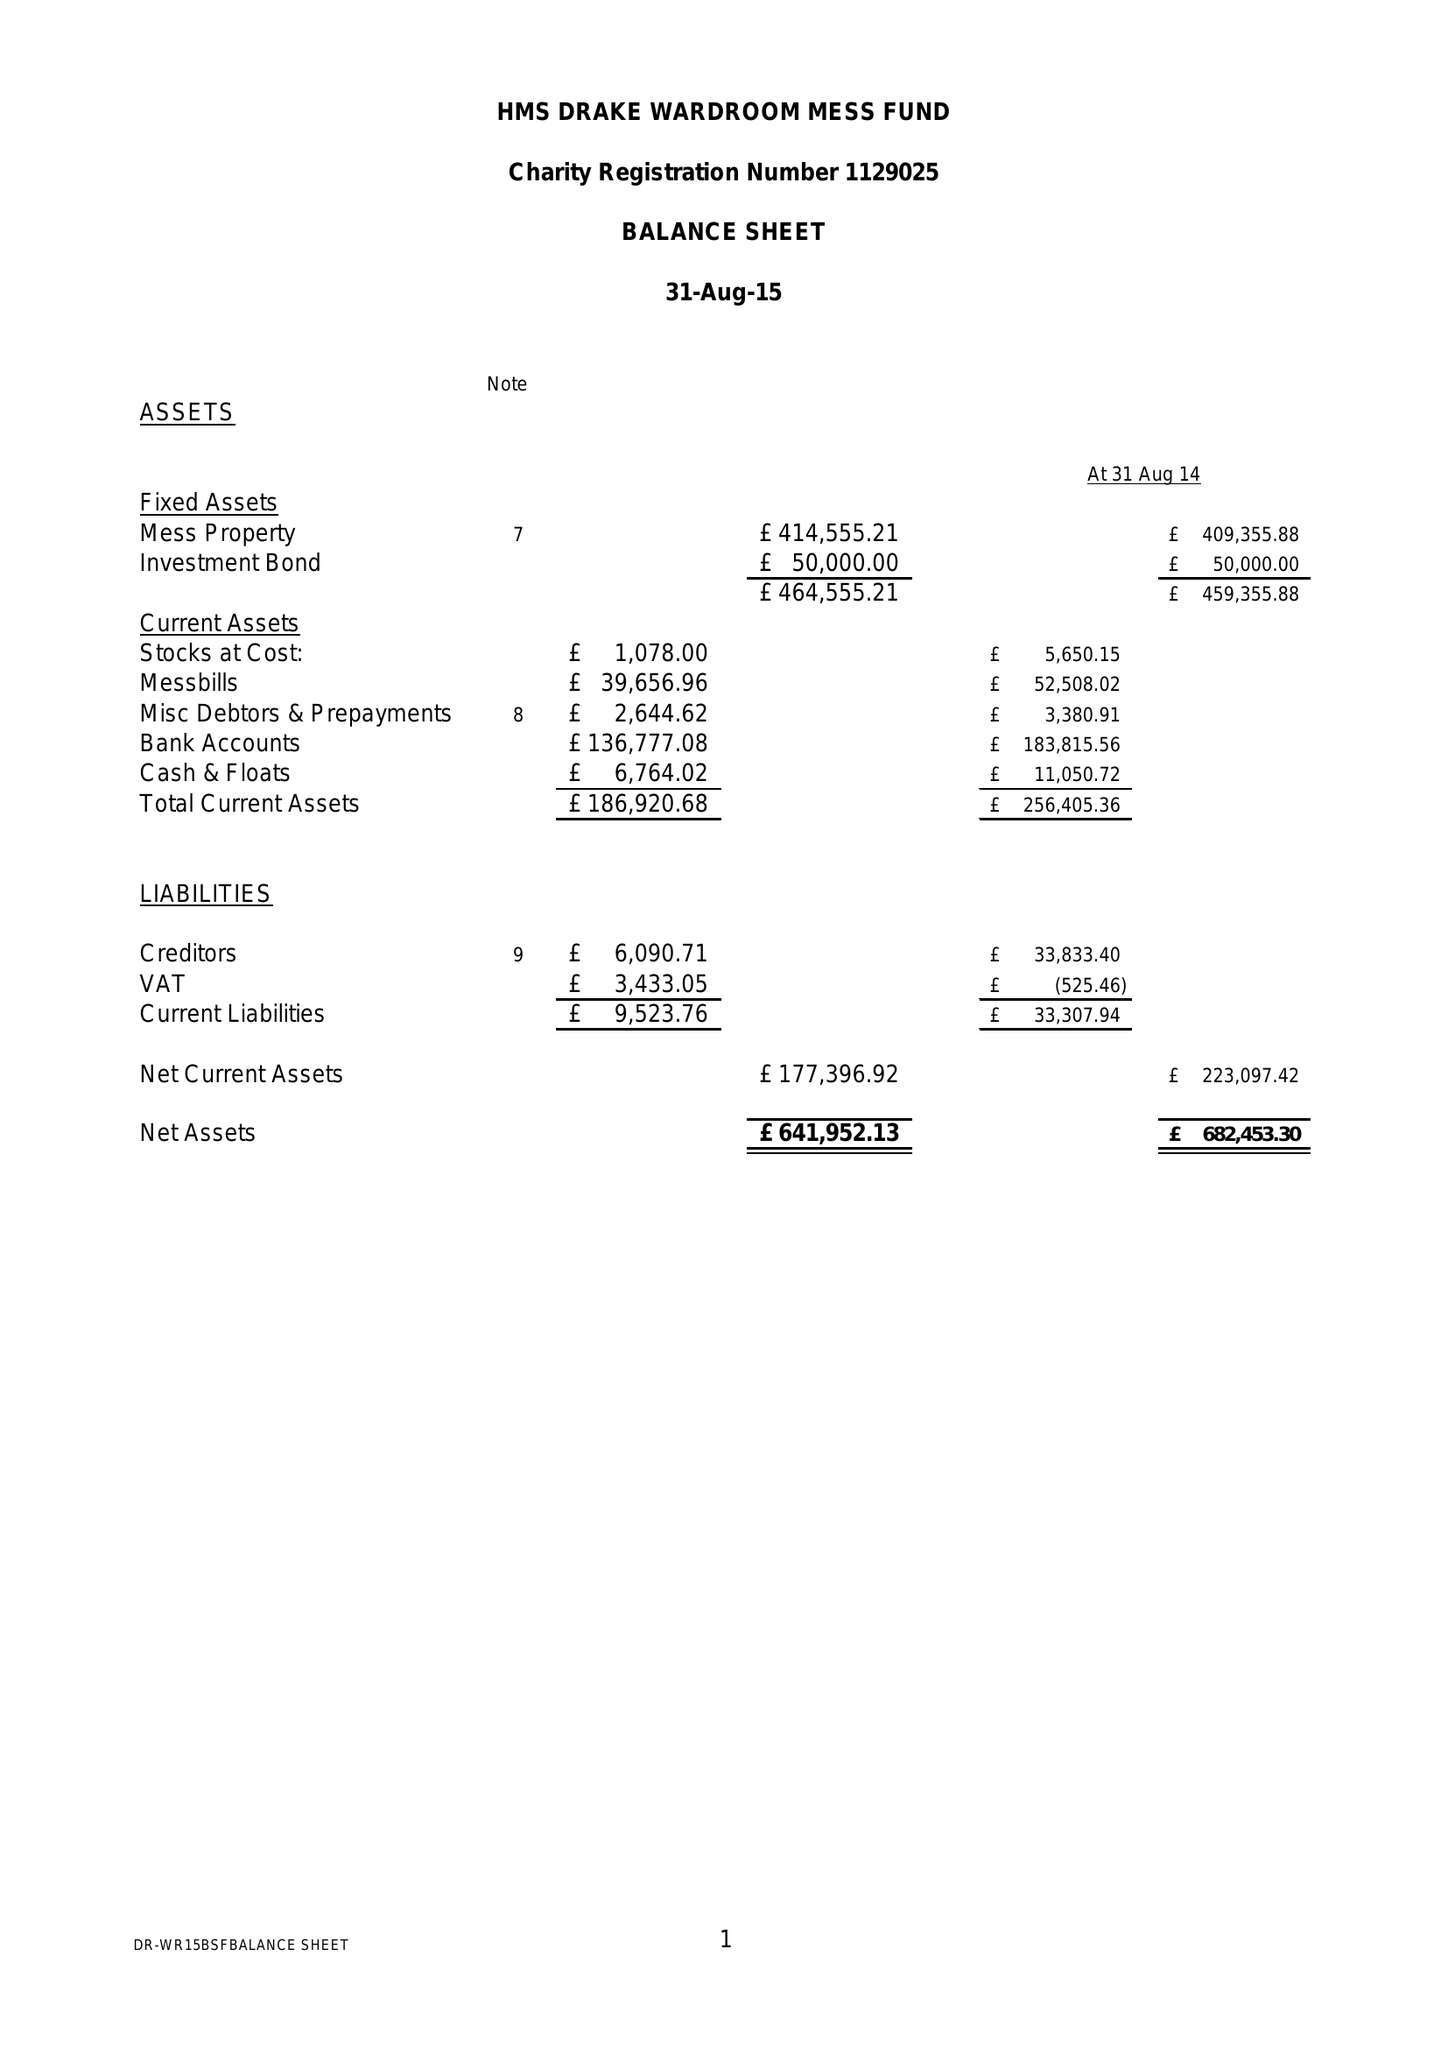What is the value for the spending_annually_in_british_pounds?
Answer the question using a single word or phrase. 219964.08 